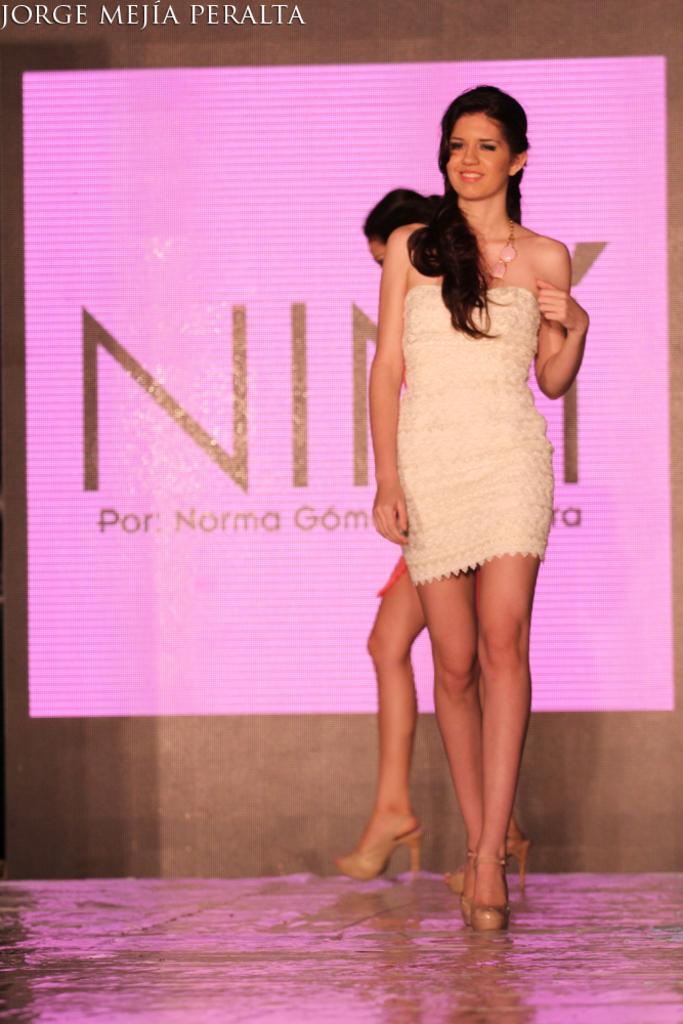Can you describe this image briefly? In this image I can see two women. One woman is smiling and they are walking on the floor. In the background there is a screen on which I can see some text. 